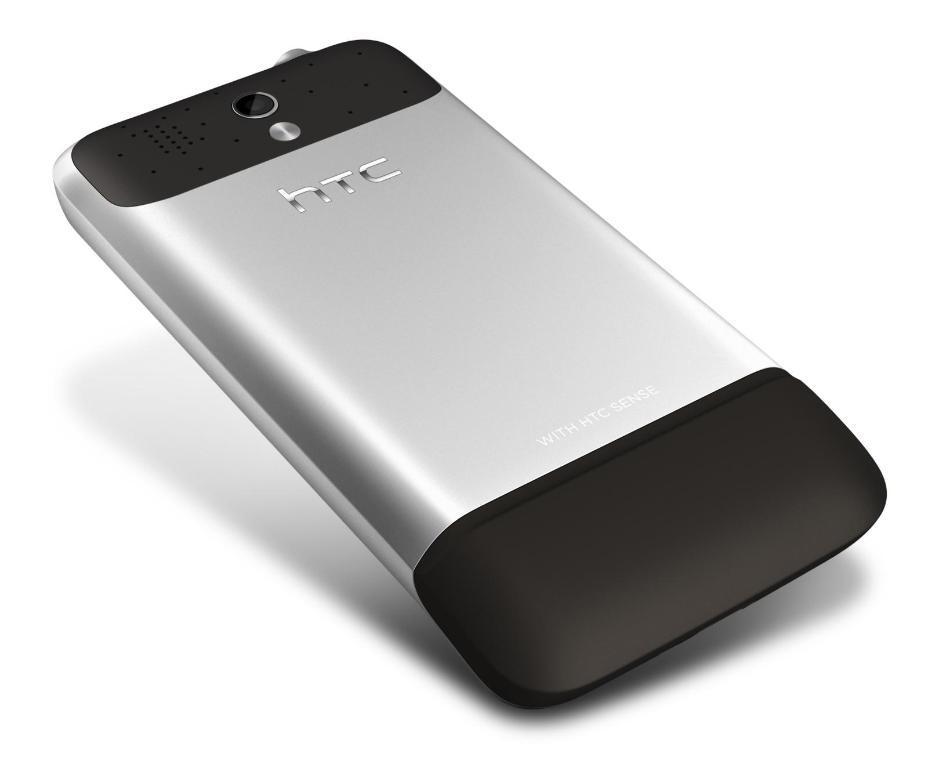How would you summarize this image in a sentence or two? In this picture we can see a htc mobile phone here, there is a white color background. 